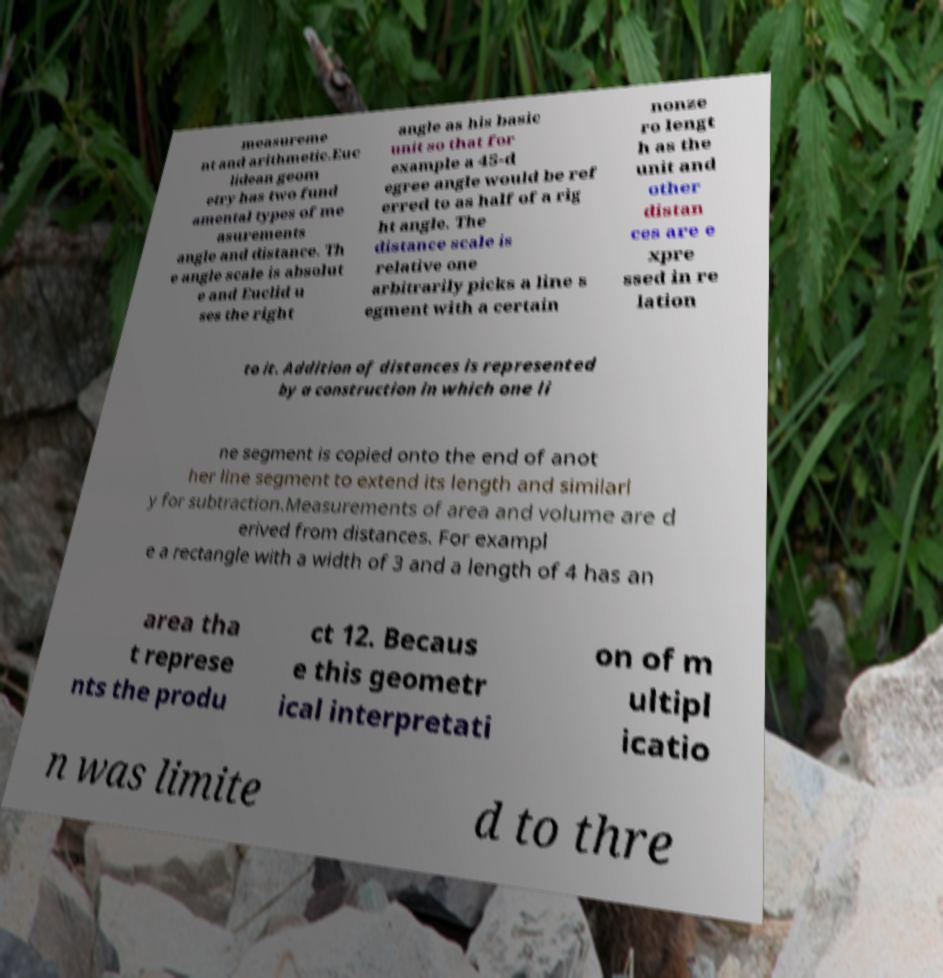For documentation purposes, I need the text within this image transcribed. Could you provide that? measureme nt and arithmetic.Euc lidean geom etry has two fund amental types of me asurements angle and distance. Th e angle scale is absolut e and Euclid u ses the right angle as his basic unit so that for example a 45-d egree angle would be ref erred to as half of a rig ht angle. The distance scale is relative one arbitrarily picks a line s egment with a certain nonze ro lengt h as the unit and other distan ces are e xpre ssed in re lation to it. Addition of distances is represented by a construction in which one li ne segment is copied onto the end of anot her line segment to extend its length and similarl y for subtraction.Measurements of area and volume are d erived from distances. For exampl e a rectangle with a width of 3 and a length of 4 has an area tha t represe nts the produ ct 12. Becaus e this geometr ical interpretati on of m ultipl icatio n was limite d to thre 